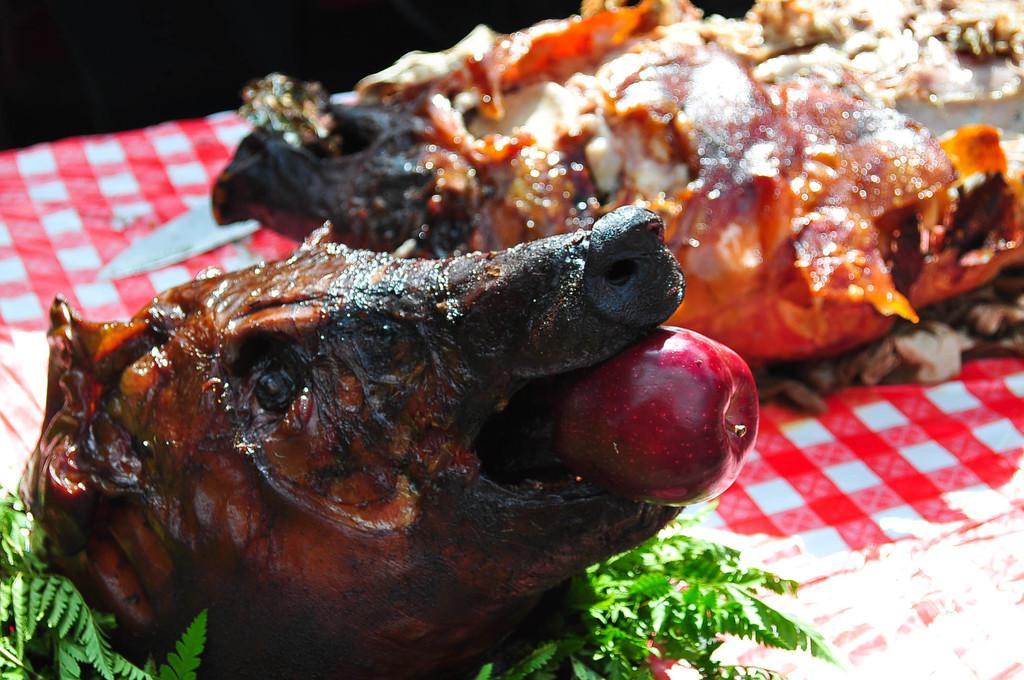In one or two sentences, can you explain what this image depicts? On a table there are food items such as meat, apple and leaves. 